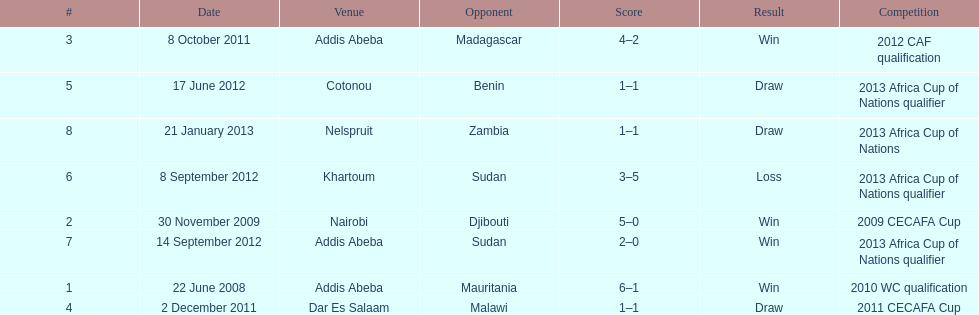For each winning game, what was their score? 6-1, 5-0, 4-2, 2-0. 